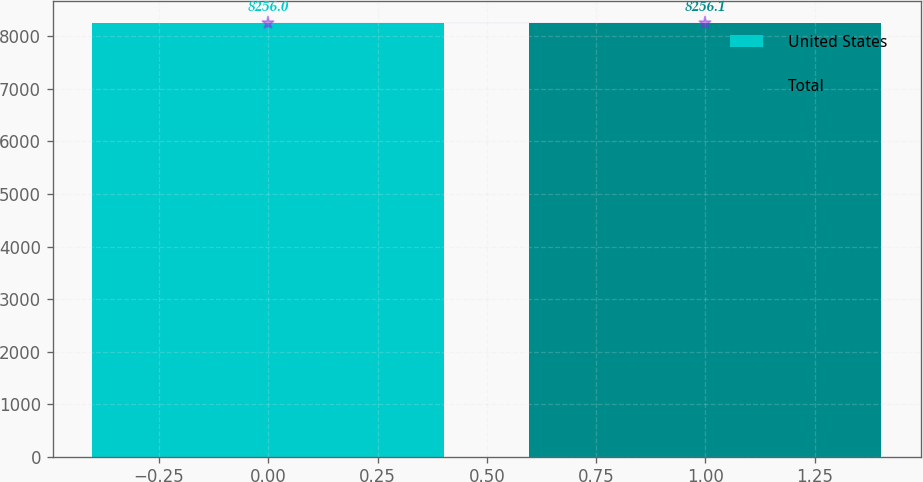<chart> <loc_0><loc_0><loc_500><loc_500><bar_chart><fcel>United States<fcel>Total<nl><fcel>8256<fcel>8256.1<nl></chart> 